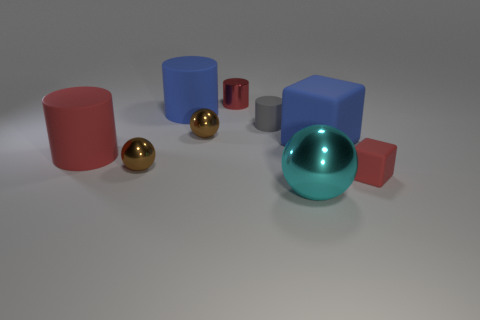Subtract all gray cylinders. How many cylinders are left? 3 Subtract 1 cylinders. How many cylinders are left? 3 Subtract all small red metallic cylinders. How many cylinders are left? 3 Subtract all cyan cylinders. Subtract all yellow cubes. How many cylinders are left? 4 Add 1 tiny gray rubber objects. How many objects exist? 10 Subtract all blocks. How many objects are left? 7 Subtract 0 purple cylinders. How many objects are left? 9 Subtract all small red balls. Subtract all blue things. How many objects are left? 7 Add 9 tiny gray rubber things. How many tiny gray rubber things are left? 10 Add 3 tiny red rubber objects. How many tiny red rubber objects exist? 4 